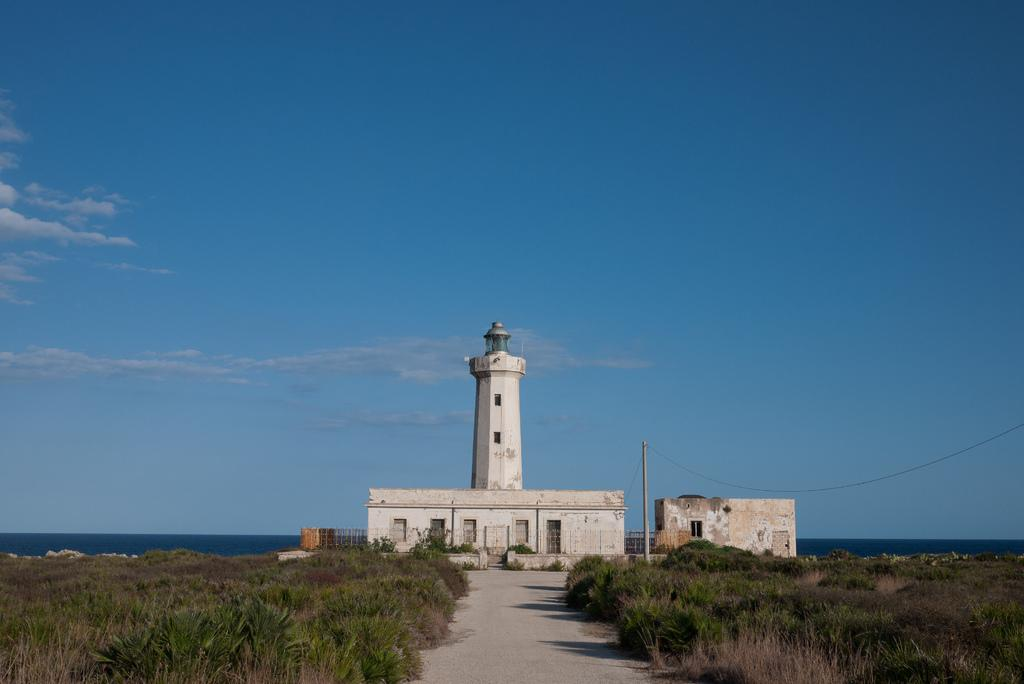What type of structures can be seen in the image? There are buildings and a house in the image. Can you describe the ground in the image? The ground in the image has grass and plants. What is visible in the image besides the structures and ground? There is water visible in the image. How would you describe the sky in the image? The sky is blue and cloudy in the image. How many fowl are flying in the rainstorm depicted in the image? There is no rainstorm depicted in the image, and no fowl are visible. What type of structure is being built by the fowl in the image? There are no fowl or structures being built by fowl in the image. 